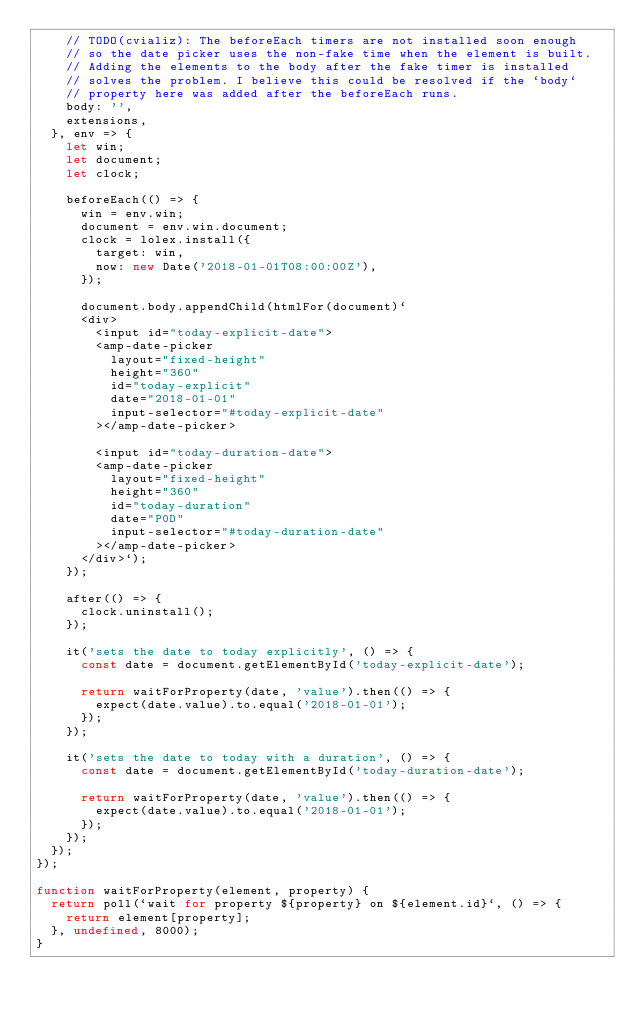<code> <loc_0><loc_0><loc_500><loc_500><_JavaScript_>    // TODO(cvializ): The beforeEach timers are not installed soon enough
    // so the date picker uses the non-fake time when the element is built.
    // Adding the elements to the body after the fake timer is installed
    // solves the problem. I believe this could be resolved if the `body`
    // property here was added after the beforeEach runs.
    body: '',
    extensions,
  }, env => {
    let win;
    let document;
    let clock;

    beforeEach(() => {
      win = env.win;
      document = env.win.document;
      clock = lolex.install({
        target: win,
        now: new Date('2018-01-01T08:00:00Z'),
      });

      document.body.appendChild(htmlFor(document)`
      <div>
        <input id="today-explicit-date">
        <amp-date-picker
          layout="fixed-height"
          height="360"
          id="today-explicit"
          date="2018-01-01"
          input-selector="#today-explicit-date"
        ></amp-date-picker>

        <input id="today-duration-date">
        <amp-date-picker
          layout="fixed-height"
          height="360"
          id="today-duration"
          date="P0D"
          input-selector="#today-duration-date"
        ></amp-date-picker>
      </div>`);
    });

    after(() => {
      clock.uninstall();
    });

    it('sets the date to today explicitly', () => {
      const date = document.getElementById('today-explicit-date');

      return waitForProperty(date, 'value').then(() => {
        expect(date.value).to.equal('2018-01-01');
      });
    });

    it('sets the date to today with a duration', () => {
      const date = document.getElementById('today-duration-date');

      return waitForProperty(date, 'value').then(() => {
        expect(date.value).to.equal('2018-01-01');
      });
    });
  });
});

function waitForProperty(element, property) {
  return poll(`wait for property ${property} on ${element.id}`, () => {
    return element[property];
  }, undefined, 8000);
}

</code> 